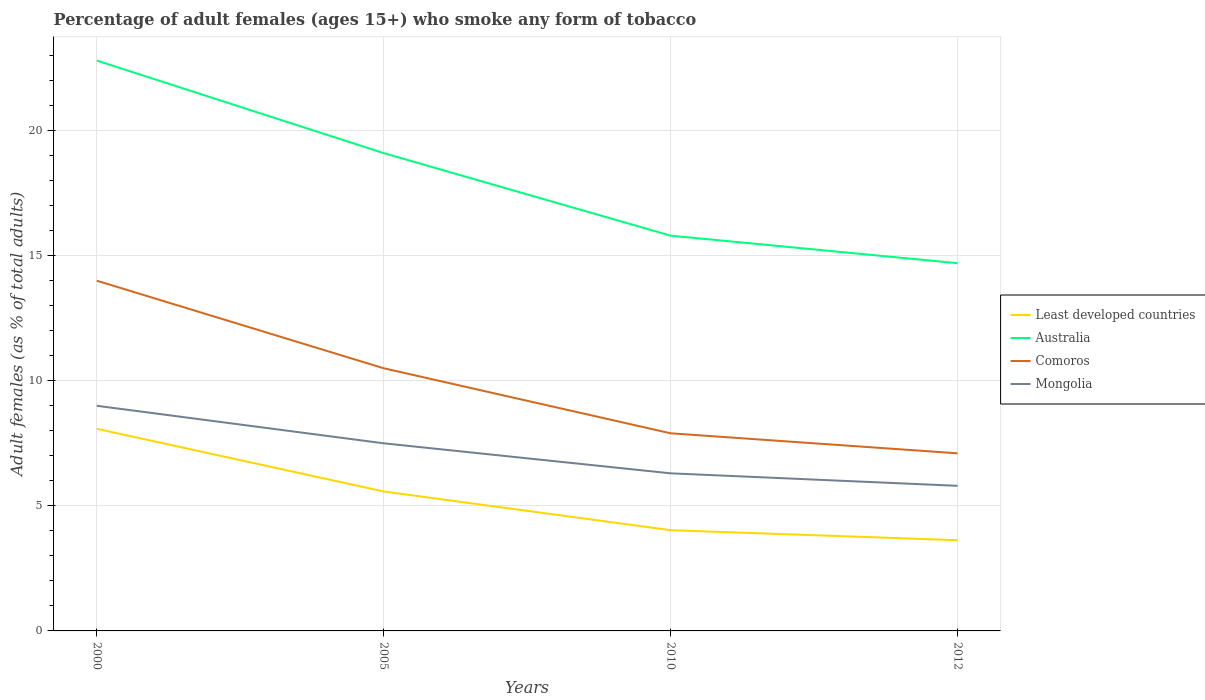Does the line corresponding to Comoros intersect with the line corresponding to Least developed countries?
Your answer should be very brief. No. What is the difference between the highest and the second highest percentage of adult females who smoke in Least developed countries?
Provide a short and direct response. 4.45. What is the difference between the highest and the lowest percentage of adult females who smoke in Comoros?
Offer a very short reply. 2. What is the difference between two consecutive major ticks on the Y-axis?
Provide a succinct answer. 5. Does the graph contain any zero values?
Provide a short and direct response. No. Does the graph contain grids?
Make the answer very short. Yes. How many legend labels are there?
Give a very brief answer. 4. How are the legend labels stacked?
Your answer should be compact. Vertical. What is the title of the graph?
Give a very brief answer. Percentage of adult females (ages 15+) who smoke any form of tobacco. Does "Saudi Arabia" appear as one of the legend labels in the graph?
Provide a short and direct response. No. What is the label or title of the X-axis?
Give a very brief answer. Years. What is the label or title of the Y-axis?
Keep it short and to the point. Adult females (as % of total adults). What is the Adult females (as % of total adults) in Least developed countries in 2000?
Make the answer very short. 8.08. What is the Adult females (as % of total adults) in Australia in 2000?
Offer a very short reply. 22.8. What is the Adult females (as % of total adults) in Comoros in 2000?
Your answer should be compact. 14. What is the Adult females (as % of total adults) in Least developed countries in 2005?
Your answer should be compact. 5.57. What is the Adult females (as % of total adults) of Australia in 2005?
Your response must be concise. 19.1. What is the Adult females (as % of total adults) in Comoros in 2005?
Your answer should be very brief. 10.5. What is the Adult females (as % of total adults) of Least developed countries in 2010?
Ensure brevity in your answer.  4.03. What is the Adult females (as % of total adults) in Australia in 2010?
Your answer should be very brief. 15.8. What is the Adult females (as % of total adults) in Least developed countries in 2012?
Make the answer very short. 3.63. What is the Adult females (as % of total adults) of Australia in 2012?
Keep it short and to the point. 14.7. What is the Adult females (as % of total adults) of Comoros in 2012?
Your response must be concise. 7.1. Across all years, what is the maximum Adult females (as % of total adults) of Least developed countries?
Provide a succinct answer. 8.08. Across all years, what is the maximum Adult females (as % of total adults) in Australia?
Provide a succinct answer. 22.8. Across all years, what is the maximum Adult females (as % of total adults) in Comoros?
Offer a very short reply. 14. Across all years, what is the maximum Adult females (as % of total adults) in Mongolia?
Give a very brief answer. 9. Across all years, what is the minimum Adult females (as % of total adults) of Least developed countries?
Provide a succinct answer. 3.63. What is the total Adult females (as % of total adults) in Least developed countries in the graph?
Provide a short and direct response. 21.31. What is the total Adult females (as % of total adults) in Australia in the graph?
Give a very brief answer. 72.4. What is the total Adult females (as % of total adults) of Comoros in the graph?
Give a very brief answer. 39.5. What is the total Adult females (as % of total adults) in Mongolia in the graph?
Offer a very short reply. 28.6. What is the difference between the Adult females (as % of total adults) of Least developed countries in 2000 and that in 2005?
Provide a short and direct response. 2.51. What is the difference between the Adult females (as % of total adults) of Comoros in 2000 and that in 2005?
Your answer should be very brief. 3.5. What is the difference between the Adult females (as % of total adults) of Least developed countries in 2000 and that in 2010?
Offer a terse response. 4.05. What is the difference between the Adult females (as % of total adults) of Least developed countries in 2000 and that in 2012?
Your answer should be compact. 4.45. What is the difference between the Adult females (as % of total adults) of Comoros in 2000 and that in 2012?
Make the answer very short. 6.9. What is the difference between the Adult females (as % of total adults) in Mongolia in 2000 and that in 2012?
Your answer should be compact. 3.2. What is the difference between the Adult females (as % of total adults) in Least developed countries in 2005 and that in 2010?
Provide a succinct answer. 1.55. What is the difference between the Adult females (as % of total adults) of Comoros in 2005 and that in 2010?
Provide a succinct answer. 2.6. What is the difference between the Adult females (as % of total adults) in Mongolia in 2005 and that in 2010?
Make the answer very short. 1.2. What is the difference between the Adult females (as % of total adults) of Least developed countries in 2005 and that in 2012?
Make the answer very short. 1.95. What is the difference between the Adult females (as % of total adults) of Least developed countries in 2010 and that in 2012?
Make the answer very short. 0.4. What is the difference between the Adult females (as % of total adults) of Australia in 2010 and that in 2012?
Keep it short and to the point. 1.1. What is the difference between the Adult females (as % of total adults) of Mongolia in 2010 and that in 2012?
Your response must be concise. 0.5. What is the difference between the Adult females (as % of total adults) of Least developed countries in 2000 and the Adult females (as % of total adults) of Australia in 2005?
Ensure brevity in your answer.  -11.02. What is the difference between the Adult females (as % of total adults) in Least developed countries in 2000 and the Adult females (as % of total adults) in Comoros in 2005?
Provide a succinct answer. -2.42. What is the difference between the Adult females (as % of total adults) in Least developed countries in 2000 and the Adult females (as % of total adults) in Mongolia in 2005?
Provide a succinct answer. 0.58. What is the difference between the Adult females (as % of total adults) in Australia in 2000 and the Adult females (as % of total adults) in Comoros in 2005?
Make the answer very short. 12.3. What is the difference between the Adult females (as % of total adults) of Australia in 2000 and the Adult females (as % of total adults) of Mongolia in 2005?
Your answer should be compact. 15.3. What is the difference between the Adult females (as % of total adults) in Comoros in 2000 and the Adult females (as % of total adults) in Mongolia in 2005?
Give a very brief answer. 6.5. What is the difference between the Adult females (as % of total adults) of Least developed countries in 2000 and the Adult females (as % of total adults) of Australia in 2010?
Keep it short and to the point. -7.72. What is the difference between the Adult females (as % of total adults) in Least developed countries in 2000 and the Adult females (as % of total adults) in Comoros in 2010?
Your answer should be very brief. 0.18. What is the difference between the Adult females (as % of total adults) of Least developed countries in 2000 and the Adult females (as % of total adults) of Mongolia in 2010?
Provide a short and direct response. 1.78. What is the difference between the Adult females (as % of total adults) of Australia in 2000 and the Adult females (as % of total adults) of Comoros in 2010?
Offer a very short reply. 14.9. What is the difference between the Adult females (as % of total adults) in Comoros in 2000 and the Adult females (as % of total adults) in Mongolia in 2010?
Offer a very short reply. 7.7. What is the difference between the Adult females (as % of total adults) in Least developed countries in 2000 and the Adult females (as % of total adults) in Australia in 2012?
Your answer should be compact. -6.62. What is the difference between the Adult females (as % of total adults) of Least developed countries in 2000 and the Adult females (as % of total adults) of Comoros in 2012?
Offer a terse response. 0.98. What is the difference between the Adult females (as % of total adults) in Least developed countries in 2000 and the Adult females (as % of total adults) in Mongolia in 2012?
Offer a terse response. 2.28. What is the difference between the Adult females (as % of total adults) in Australia in 2000 and the Adult females (as % of total adults) in Comoros in 2012?
Your response must be concise. 15.7. What is the difference between the Adult females (as % of total adults) of Australia in 2000 and the Adult females (as % of total adults) of Mongolia in 2012?
Your answer should be compact. 17. What is the difference between the Adult females (as % of total adults) of Least developed countries in 2005 and the Adult females (as % of total adults) of Australia in 2010?
Offer a very short reply. -10.23. What is the difference between the Adult females (as % of total adults) of Least developed countries in 2005 and the Adult females (as % of total adults) of Comoros in 2010?
Provide a short and direct response. -2.33. What is the difference between the Adult females (as % of total adults) of Least developed countries in 2005 and the Adult females (as % of total adults) of Mongolia in 2010?
Ensure brevity in your answer.  -0.73. What is the difference between the Adult females (as % of total adults) of Australia in 2005 and the Adult females (as % of total adults) of Comoros in 2010?
Your response must be concise. 11.2. What is the difference between the Adult females (as % of total adults) in Comoros in 2005 and the Adult females (as % of total adults) in Mongolia in 2010?
Ensure brevity in your answer.  4.2. What is the difference between the Adult females (as % of total adults) of Least developed countries in 2005 and the Adult females (as % of total adults) of Australia in 2012?
Provide a short and direct response. -9.13. What is the difference between the Adult females (as % of total adults) of Least developed countries in 2005 and the Adult females (as % of total adults) of Comoros in 2012?
Your answer should be compact. -1.53. What is the difference between the Adult females (as % of total adults) in Least developed countries in 2005 and the Adult females (as % of total adults) in Mongolia in 2012?
Keep it short and to the point. -0.23. What is the difference between the Adult females (as % of total adults) of Australia in 2005 and the Adult females (as % of total adults) of Mongolia in 2012?
Your answer should be compact. 13.3. What is the difference between the Adult females (as % of total adults) in Least developed countries in 2010 and the Adult females (as % of total adults) in Australia in 2012?
Provide a succinct answer. -10.67. What is the difference between the Adult females (as % of total adults) of Least developed countries in 2010 and the Adult females (as % of total adults) of Comoros in 2012?
Your response must be concise. -3.07. What is the difference between the Adult females (as % of total adults) in Least developed countries in 2010 and the Adult females (as % of total adults) in Mongolia in 2012?
Your response must be concise. -1.77. What is the average Adult females (as % of total adults) in Least developed countries per year?
Your response must be concise. 5.33. What is the average Adult females (as % of total adults) of Australia per year?
Make the answer very short. 18.1. What is the average Adult females (as % of total adults) of Comoros per year?
Your answer should be compact. 9.88. What is the average Adult females (as % of total adults) of Mongolia per year?
Offer a very short reply. 7.15. In the year 2000, what is the difference between the Adult females (as % of total adults) of Least developed countries and Adult females (as % of total adults) of Australia?
Provide a succinct answer. -14.72. In the year 2000, what is the difference between the Adult females (as % of total adults) of Least developed countries and Adult females (as % of total adults) of Comoros?
Provide a short and direct response. -5.92. In the year 2000, what is the difference between the Adult females (as % of total adults) in Least developed countries and Adult females (as % of total adults) in Mongolia?
Keep it short and to the point. -0.92. In the year 2005, what is the difference between the Adult females (as % of total adults) in Least developed countries and Adult females (as % of total adults) in Australia?
Your answer should be compact. -13.53. In the year 2005, what is the difference between the Adult females (as % of total adults) in Least developed countries and Adult females (as % of total adults) in Comoros?
Provide a short and direct response. -4.93. In the year 2005, what is the difference between the Adult females (as % of total adults) of Least developed countries and Adult females (as % of total adults) of Mongolia?
Offer a very short reply. -1.93. In the year 2005, what is the difference between the Adult females (as % of total adults) in Australia and Adult females (as % of total adults) in Mongolia?
Provide a succinct answer. 11.6. In the year 2010, what is the difference between the Adult females (as % of total adults) in Least developed countries and Adult females (as % of total adults) in Australia?
Offer a very short reply. -11.77. In the year 2010, what is the difference between the Adult females (as % of total adults) of Least developed countries and Adult females (as % of total adults) of Comoros?
Provide a short and direct response. -3.87. In the year 2010, what is the difference between the Adult females (as % of total adults) of Least developed countries and Adult females (as % of total adults) of Mongolia?
Offer a terse response. -2.27. In the year 2010, what is the difference between the Adult females (as % of total adults) of Australia and Adult females (as % of total adults) of Comoros?
Provide a succinct answer. 7.9. In the year 2010, what is the difference between the Adult females (as % of total adults) of Australia and Adult females (as % of total adults) of Mongolia?
Your answer should be very brief. 9.5. In the year 2012, what is the difference between the Adult females (as % of total adults) of Least developed countries and Adult females (as % of total adults) of Australia?
Make the answer very short. -11.07. In the year 2012, what is the difference between the Adult females (as % of total adults) of Least developed countries and Adult females (as % of total adults) of Comoros?
Your answer should be very brief. -3.47. In the year 2012, what is the difference between the Adult females (as % of total adults) of Least developed countries and Adult females (as % of total adults) of Mongolia?
Give a very brief answer. -2.17. In the year 2012, what is the difference between the Adult females (as % of total adults) in Australia and Adult females (as % of total adults) in Comoros?
Give a very brief answer. 7.6. In the year 2012, what is the difference between the Adult females (as % of total adults) of Comoros and Adult females (as % of total adults) of Mongolia?
Your response must be concise. 1.3. What is the ratio of the Adult females (as % of total adults) in Least developed countries in 2000 to that in 2005?
Ensure brevity in your answer.  1.45. What is the ratio of the Adult females (as % of total adults) in Australia in 2000 to that in 2005?
Offer a very short reply. 1.19. What is the ratio of the Adult females (as % of total adults) of Comoros in 2000 to that in 2005?
Give a very brief answer. 1.33. What is the ratio of the Adult females (as % of total adults) in Least developed countries in 2000 to that in 2010?
Your answer should be compact. 2.01. What is the ratio of the Adult females (as % of total adults) in Australia in 2000 to that in 2010?
Your answer should be very brief. 1.44. What is the ratio of the Adult females (as % of total adults) of Comoros in 2000 to that in 2010?
Your response must be concise. 1.77. What is the ratio of the Adult females (as % of total adults) in Mongolia in 2000 to that in 2010?
Your answer should be compact. 1.43. What is the ratio of the Adult females (as % of total adults) in Least developed countries in 2000 to that in 2012?
Give a very brief answer. 2.23. What is the ratio of the Adult females (as % of total adults) of Australia in 2000 to that in 2012?
Offer a terse response. 1.55. What is the ratio of the Adult females (as % of total adults) in Comoros in 2000 to that in 2012?
Offer a terse response. 1.97. What is the ratio of the Adult females (as % of total adults) in Mongolia in 2000 to that in 2012?
Your answer should be compact. 1.55. What is the ratio of the Adult females (as % of total adults) of Least developed countries in 2005 to that in 2010?
Offer a terse response. 1.38. What is the ratio of the Adult females (as % of total adults) of Australia in 2005 to that in 2010?
Offer a terse response. 1.21. What is the ratio of the Adult females (as % of total adults) of Comoros in 2005 to that in 2010?
Keep it short and to the point. 1.33. What is the ratio of the Adult females (as % of total adults) in Mongolia in 2005 to that in 2010?
Give a very brief answer. 1.19. What is the ratio of the Adult females (as % of total adults) in Least developed countries in 2005 to that in 2012?
Ensure brevity in your answer.  1.54. What is the ratio of the Adult females (as % of total adults) of Australia in 2005 to that in 2012?
Ensure brevity in your answer.  1.3. What is the ratio of the Adult females (as % of total adults) in Comoros in 2005 to that in 2012?
Your answer should be compact. 1.48. What is the ratio of the Adult females (as % of total adults) of Mongolia in 2005 to that in 2012?
Provide a succinct answer. 1.29. What is the ratio of the Adult females (as % of total adults) in Least developed countries in 2010 to that in 2012?
Keep it short and to the point. 1.11. What is the ratio of the Adult females (as % of total adults) in Australia in 2010 to that in 2012?
Your response must be concise. 1.07. What is the ratio of the Adult females (as % of total adults) of Comoros in 2010 to that in 2012?
Your answer should be very brief. 1.11. What is the ratio of the Adult females (as % of total adults) in Mongolia in 2010 to that in 2012?
Your answer should be compact. 1.09. What is the difference between the highest and the second highest Adult females (as % of total adults) in Least developed countries?
Keep it short and to the point. 2.51. What is the difference between the highest and the lowest Adult females (as % of total adults) in Least developed countries?
Make the answer very short. 4.45. What is the difference between the highest and the lowest Adult females (as % of total adults) of Australia?
Give a very brief answer. 8.1. What is the difference between the highest and the lowest Adult females (as % of total adults) in Comoros?
Make the answer very short. 6.9. What is the difference between the highest and the lowest Adult females (as % of total adults) in Mongolia?
Give a very brief answer. 3.2. 